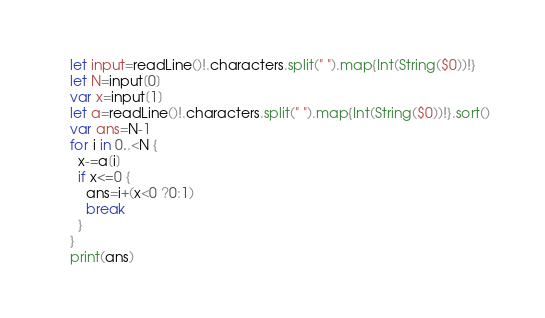<code> <loc_0><loc_0><loc_500><loc_500><_Swift_>let input=readLine()!.characters.split(" ").map{Int(String($0))!}
let N=input[0]
var x=input[1]
let a=readLine()!.characters.split(" ").map{Int(String($0))!}.sort()
var ans=N-1
for i in 0..<N {
  x-=a[i]
  if x<=0 {
    ans=i+(x<0 ?0:1)
    break
  }
}
print(ans)</code> 